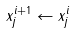Convert formula to latex. <formula><loc_0><loc_0><loc_500><loc_500>x _ { j } ^ { i + 1 } \gets x _ { j } ^ { i }</formula> 